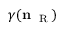Convert formula to latex. <formula><loc_0><loc_0><loc_500><loc_500>\gamma ( { n } _ { R } )</formula> 